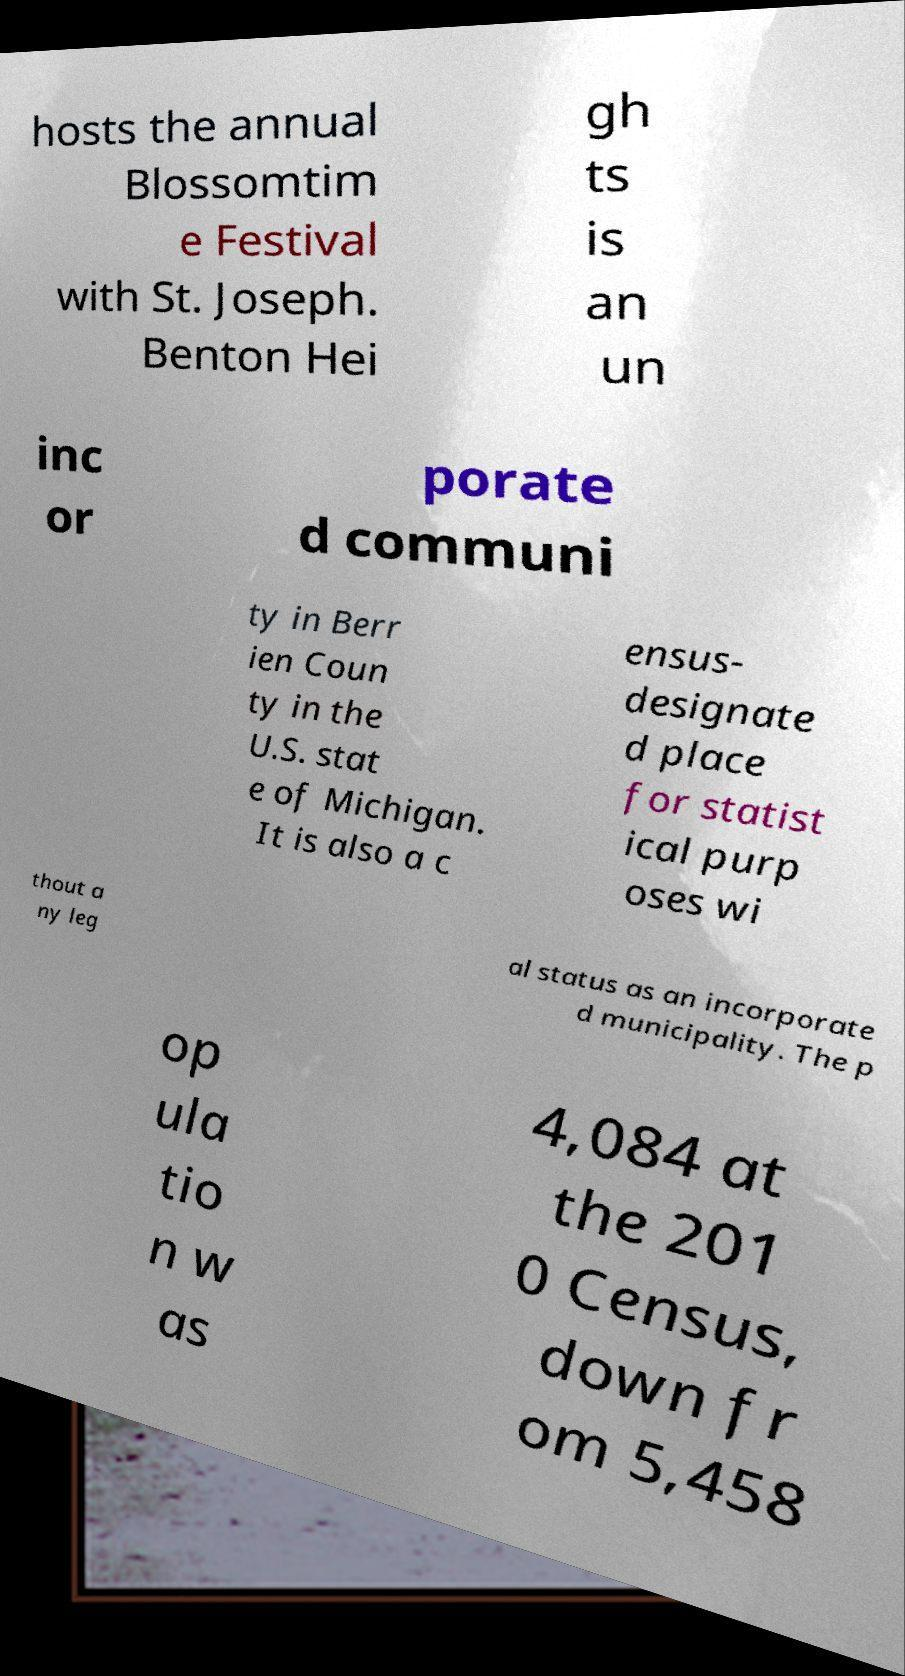I need the written content from this picture converted into text. Can you do that? hosts the annual Blossomtim e Festival with St. Joseph. Benton Hei gh ts is an un inc or porate d communi ty in Berr ien Coun ty in the U.S. stat e of Michigan. It is also a c ensus- designate d place for statist ical purp oses wi thout a ny leg al status as an incorporate d municipality. The p op ula tio n w as 4,084 at the 201 0 Census, down fr om 5,458 